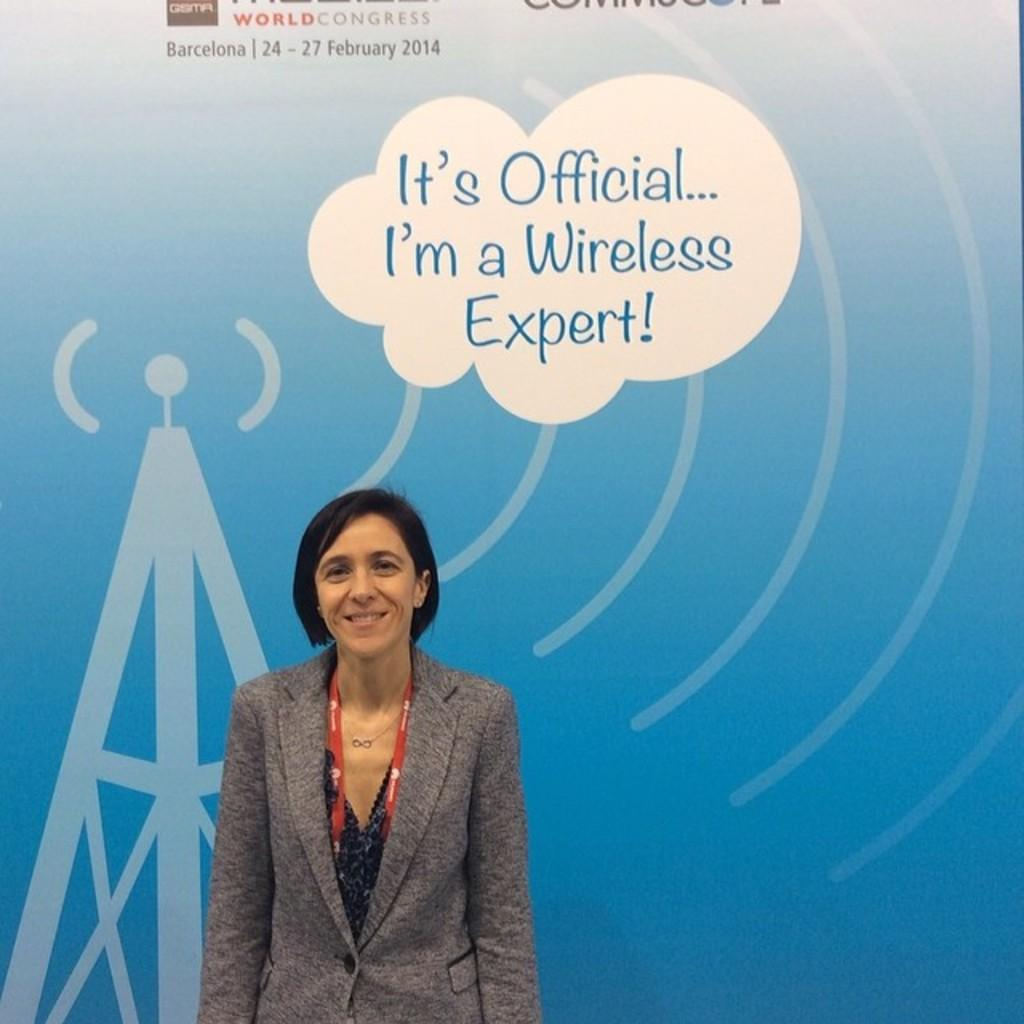Who is present in the image? There is a woman in the image. What is the woman doing in the image? The woman is standing and smiling. What type of advertisement or display is the image part of? The image appears to be a hoarding. What can be seen on the hoarding besides the woman? There are pictures and letters on the hoarding. What type of twig can be seen in the woman's hand in the image? There is no twig present in the woman's hand or in the image. 